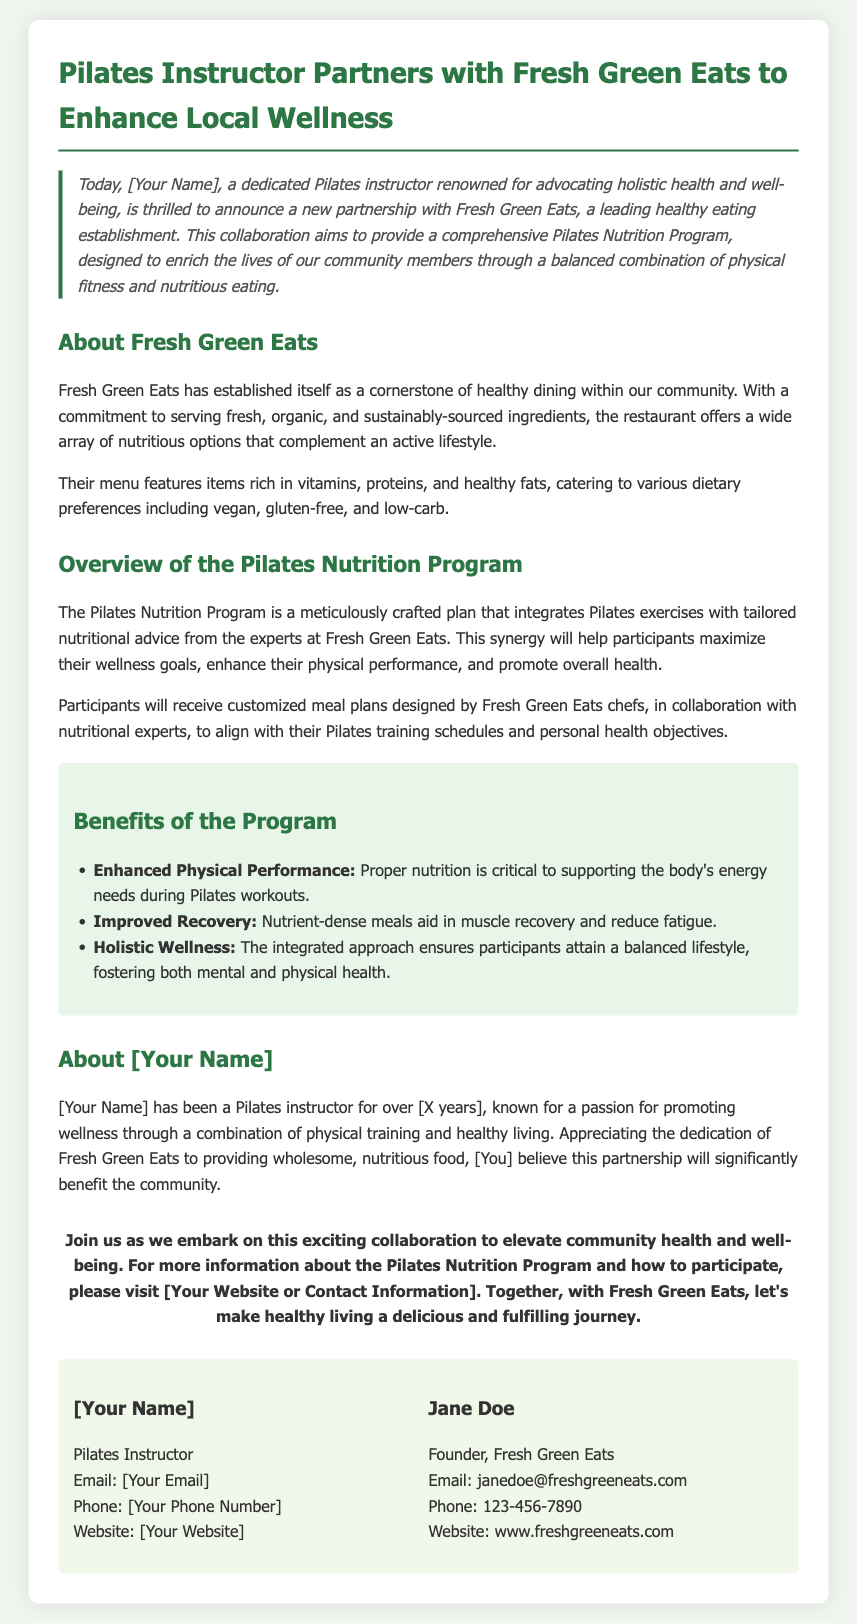What is the name of the healthy restaurant collaborating with the Pilates instructor? The restaurant's name is specifically mentioned as a partner in the collaboration.
Answer: Fresh Green Eats Who is the founder of Fresh Green Eats? The document explicitly states the name of the founder in the contact information section.
Answer: Jane Doe What is the primary goal of the Pilates Nutrition Program? The primary goal is highlighted in the introduction and overview sections and indicates the program's focus.
Answer: Enrich the lives of community members How many years has the Pilates instructor been teaching? The document provides a placeholder for this specific information.
Answer: [X years] What is one of the benefits of the Pilates Nutrition Program? The benefits are listed and described in a specific section of the document.
Answer: Enhanced Physical Performance What type of dietary preferences does Fresh Green Eats cater to? The document details various dietary preferences supported by the restaurant.
Answer: Vegan, gluten-free, and low-carb What role do Fresh Green Eats chefs play in the program? The document explains the collaboration between chefs and experts in shaping the program's offerings.
Answer: Customize meal plans What is emphasized as critical for proper physical performance during Pilates workouts? The importance of nutrition is specifically highlighted in the context of the program's effectiveness.
Answer: Proper nutrition What is the overall theme of the press release? The document describes the nature and purpose of the partnership, indicating its collective aim.
Answer: Community health and well-being 